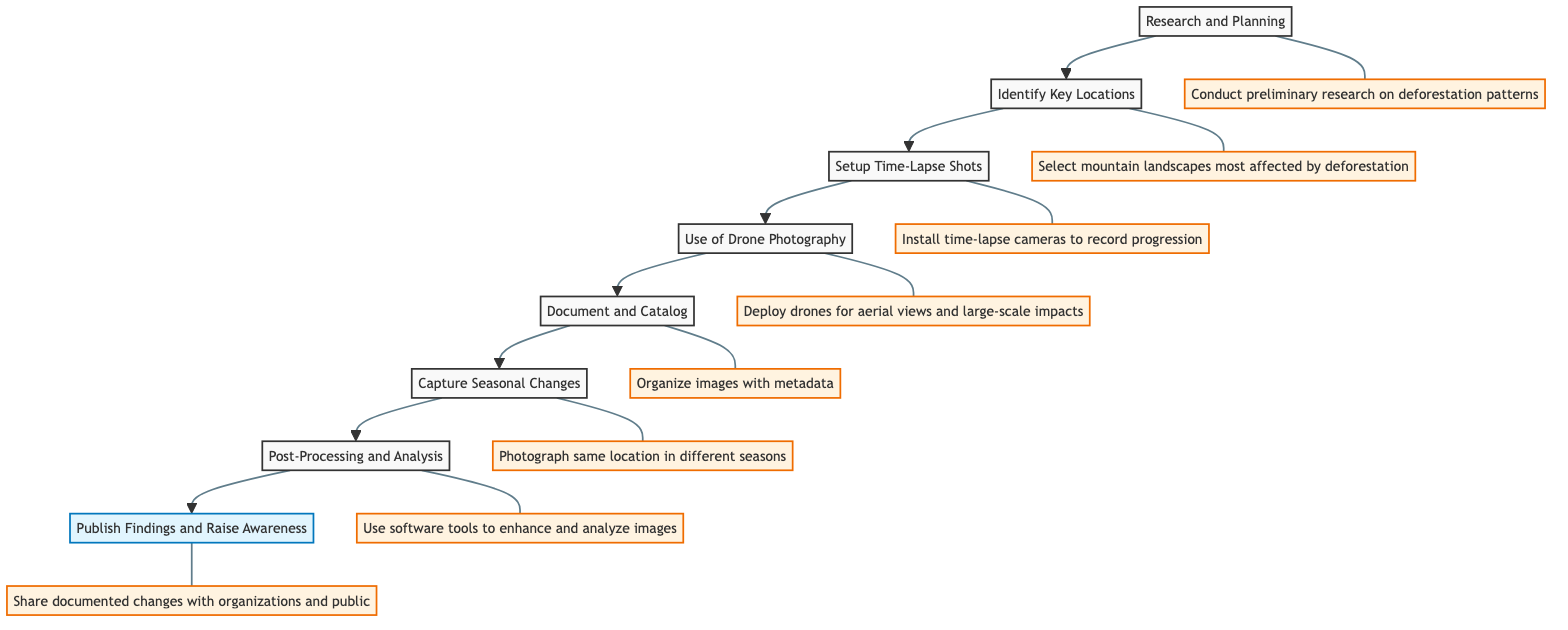What is the first step in the diagram? The first step at the bottom of the flowchart is "Research and Planning." This is where the process begins, laying the groundwork for the subsequent steps.
Answer: Research and Planning How many total steps are illustrated in the diagram? There are a total of eight steps represented in the flowchart, each connected sequentially from the beginning to the end.
Answer: Eight Which step comes after "Document and Catalog"? The step that follows "Document and Catalog" is "Capture Seasonal Changes." This can be inferred by moving upward from the "Document and Catalog" node in the diagram.
Answer: Capture Seasonal Changes What is the last step in the process? The last step, positioned at the top of the flowchart, is "Publish Findings and Raise Awareness." This completes the flow of instructions.
Answer: Publish Findings and Raise Awareness Which two steps are connected directly before the "Post-Processing and Analysis" step? The steps that directly precede "Post-Processing and Analysis" are "Capture Seasonal Changes" and "Document and Catalog." These two steps lead into the analysis of the captured images.
Answer: Capture Seasonal Changes and Document and Catalog What action is taken during the "Use of Drone Photography" step? In this step, drones are deployed to capture aerial views of deforestation, highlighting impacts that may not be visible from the ground level. The connection is drawn directly from the corresponding node in the flowchart.
Answer: Deploy drones Which step requires organization of images with specific metadata? The organization of images with metadata occurs in the "Document and Catalog" step, which focuses on cataloging the photographs taken.
Answer: Document and Catalog What do the "Setup Time-Lapse Shots" and "Use of Drone Photography" steps have in common? Both steps involve capturing images in a unique format: time-lapse shots continuously record progression, while drone photography captures expansive views. They both focus on innovative methods of documenting changes.
Answer: Innovative capturing methods 